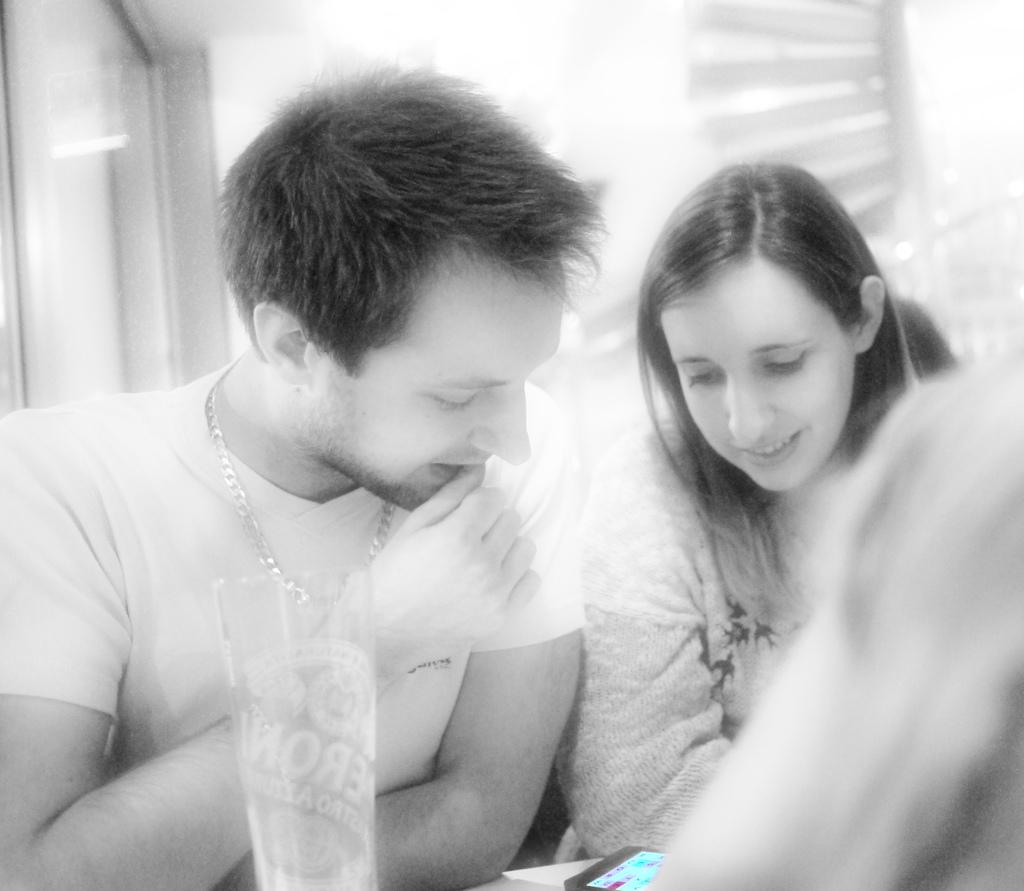How many people are in the image? There are two people in the image. What are the people doing in the image? The people are sitting in a room and looking at a cell phone. What can be seen on the table in the image? There is a glass on a table in the image. Can you describe the background of the image? The background of the image is blurry. What type of cactus is on the table next to the glass in the image? There is no cactus present in the image; only a glass can be seen on the table. What book is the person reading in the image? There is no book visible in the image; the people are looking at a cell phone. 